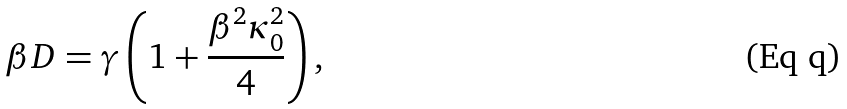Convert formula to latex. <formula><loc_0><loc_0><loc_500><loc_500>\beta D = \gamma \left ( 1 + \frac { \beta ^ { 2 } \kappa _ { 0 } ^ { 2 } } { 4 } \right ) ,</formula> 